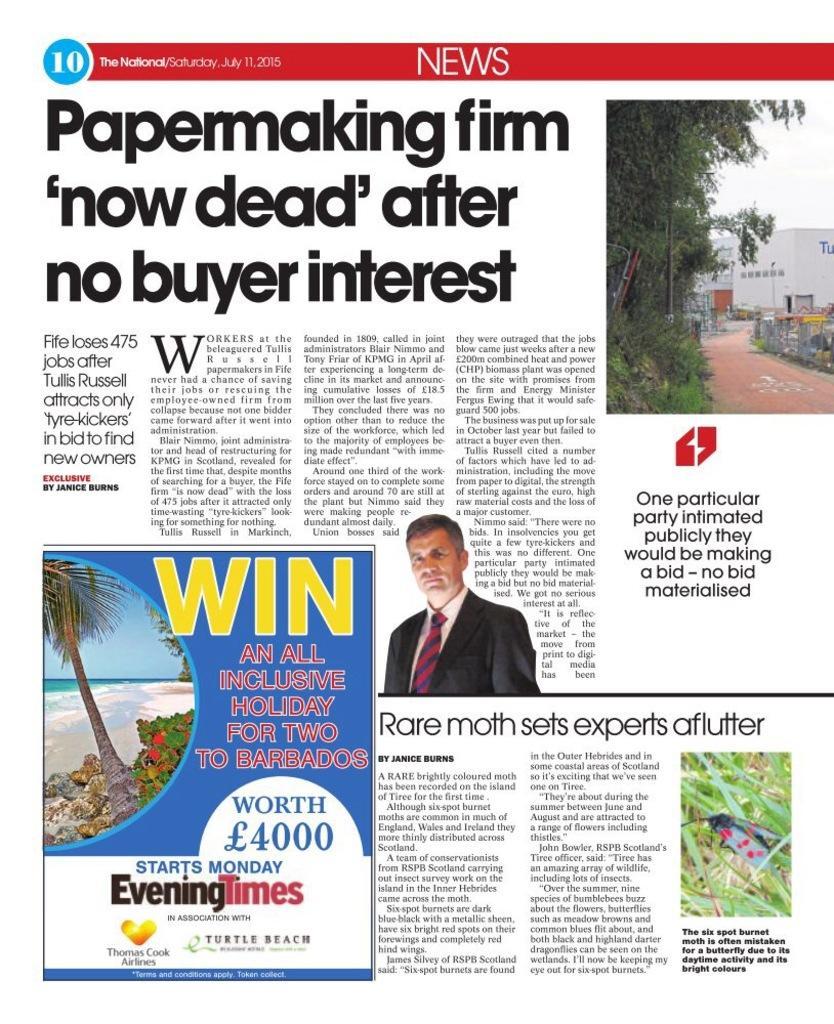Could you give a brief overview of what you see in this image? The image looks like it is a newspaper column. In this picture we can see text. In the center of the picture there is a person. On the left there are trees, beach and a water body. On the right we can see trees, building, path and sky. 